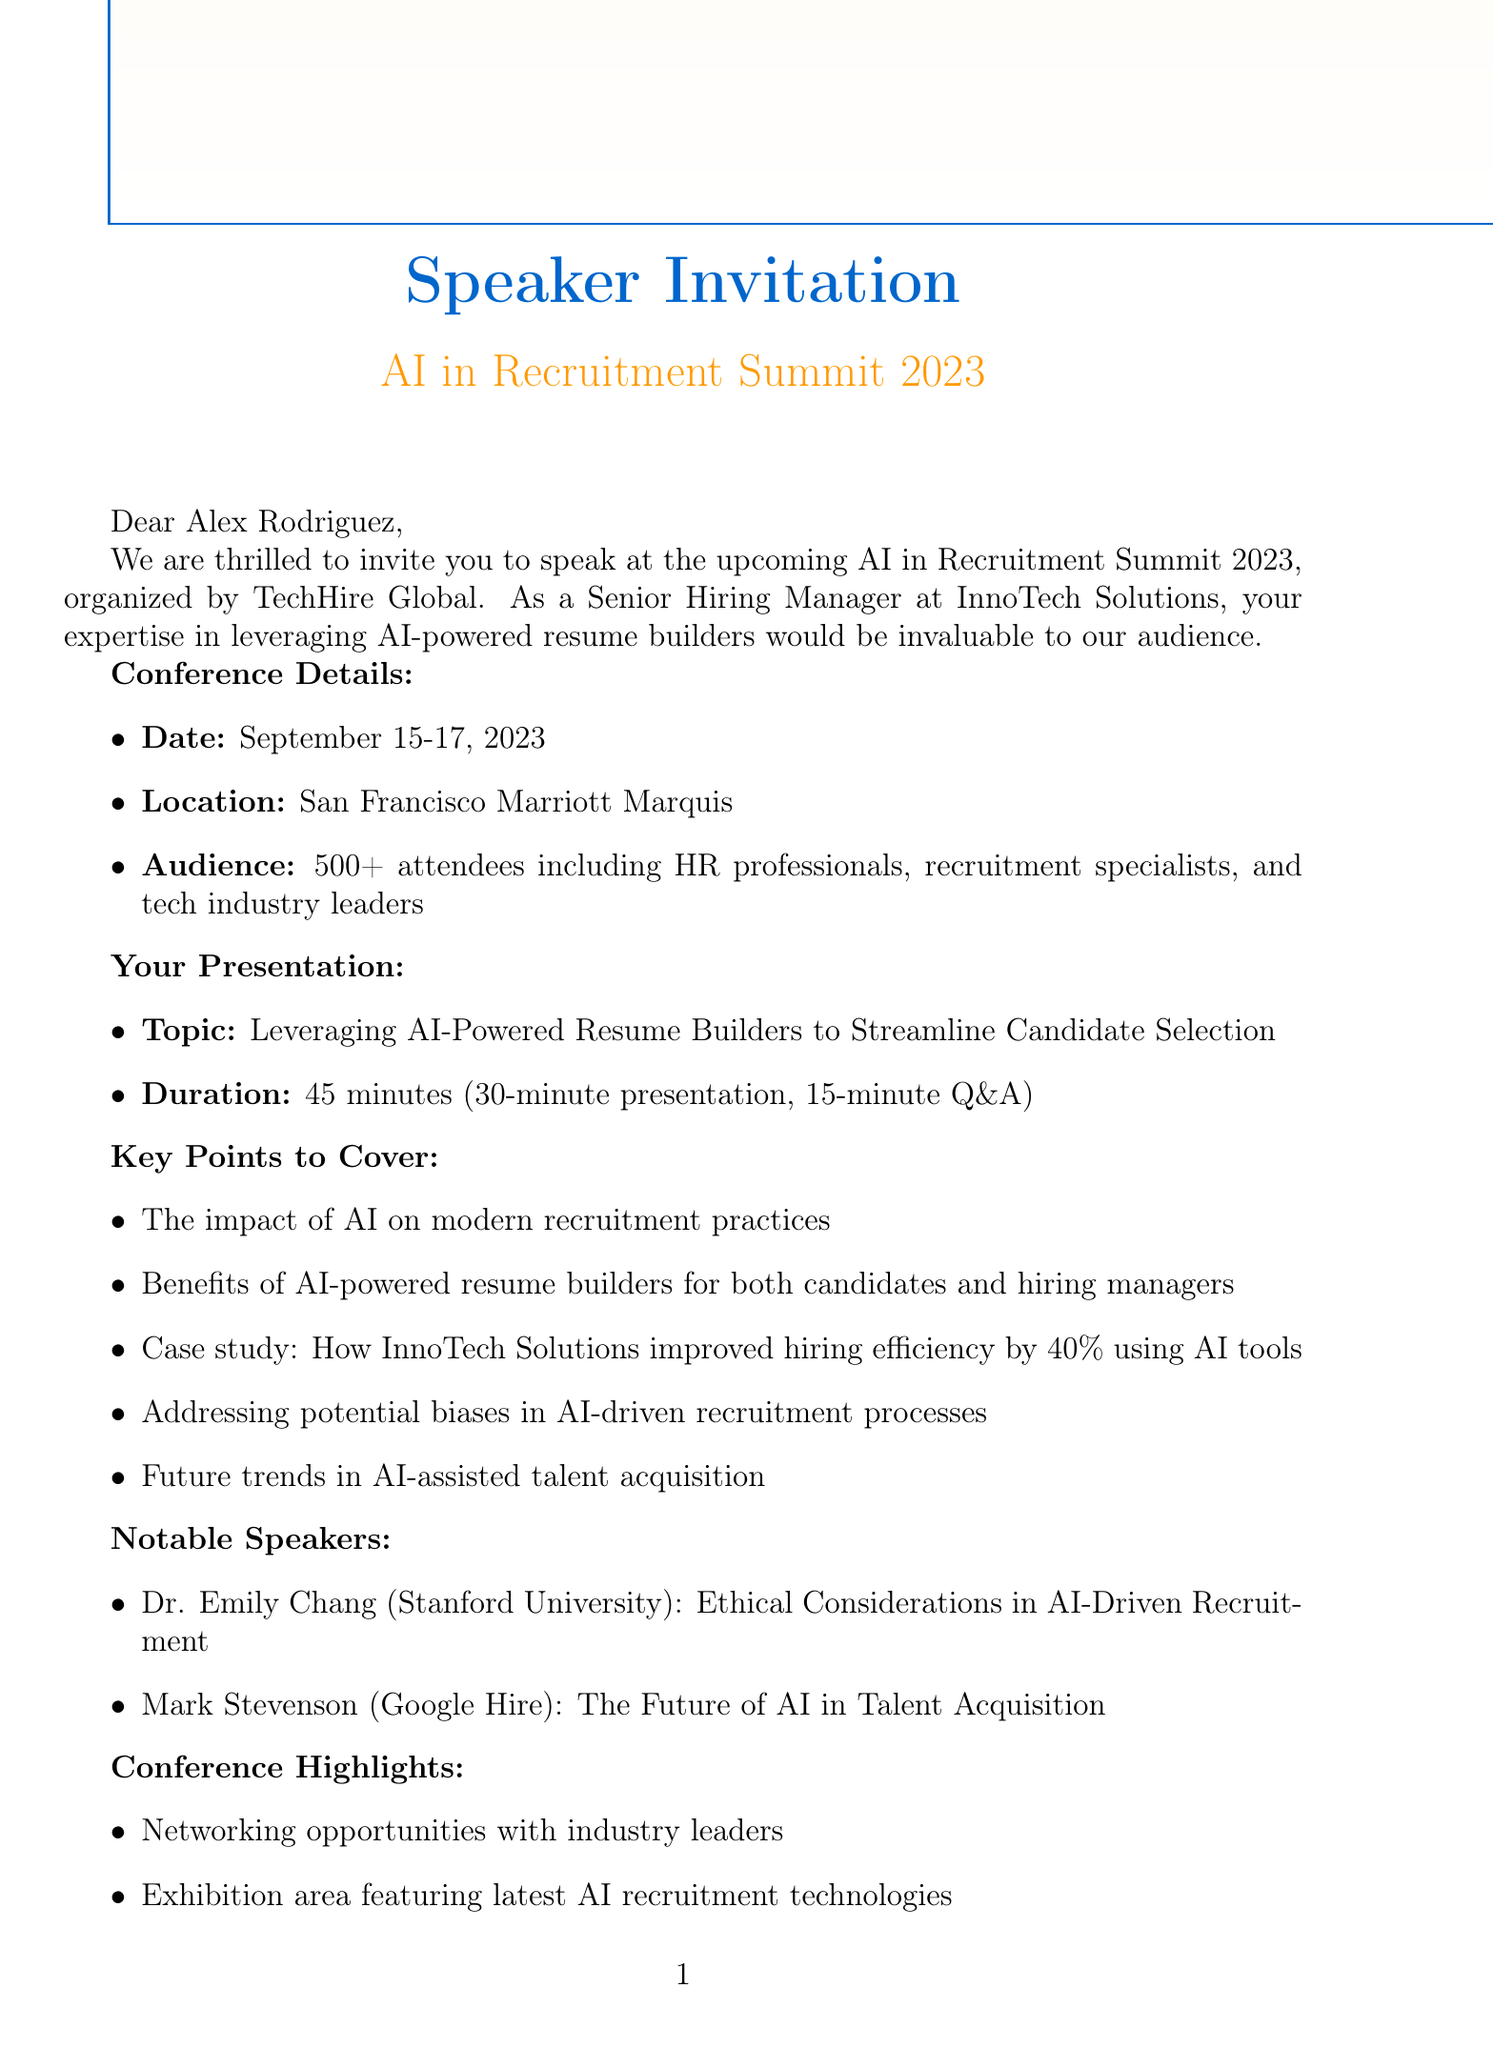What is the name of the conference? The name of the conference, as mentioned in the document, is "AI in Recruitment Summit 2023."
Answer: AI in Recruitment Summit 2023 Who is the speaker invited to the conference? The invited speaker is referred to by name in the document as "Alex Rodriguez."
Answer: Alex Rodriguez How long is the speaking slot for the presentation? The duration of the speaking slot is explicitly stated in the document as 45 minutes.
Answer: 45 minutes What is one key point mentioned regarding AI-powered resume builders? The document lists benefits of AI-powered resume builders for both candidates and hiring managers as a key point.
Answer: Benefits of AI-powered resume builders for both candidates and hiring managers What is the location of the conference? The conference is set to take place at the San Francisco Marriott Marquis, as stated in the document.
Answer: San Francisco Marriott Marquis How many notable speakers are mentioned in the document? The document mentions a total of two notable speakers.
Answer: 2 What type of session follows the presentation? A 15-minute Q&A session follows the 30-minute presentation, as detailed in the document.
Answer: 15-minute Q&A session What is one post-conference opportunity mentioned? The document provides the opportunity for a potential feature in TechHire Global's annual report on AI in recruitment.
Answer: Potential feature in TechHire Global's annual report on AI in recruitment 